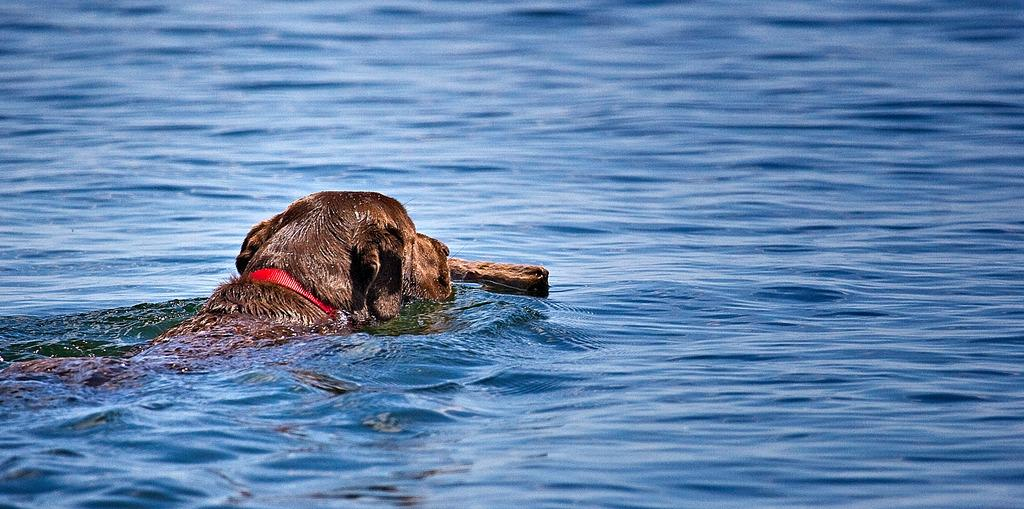What type of animal is in the water in the image? There is a dog in the water in the image. What type of light can be seen illuminating the cellar in the image? There is no cellar present in the image, and therefore no light illuminating it. What type of voyage is the dog embarking on in the image? There is no indication of a voyage in the image; it simply shows a dog in the water. 